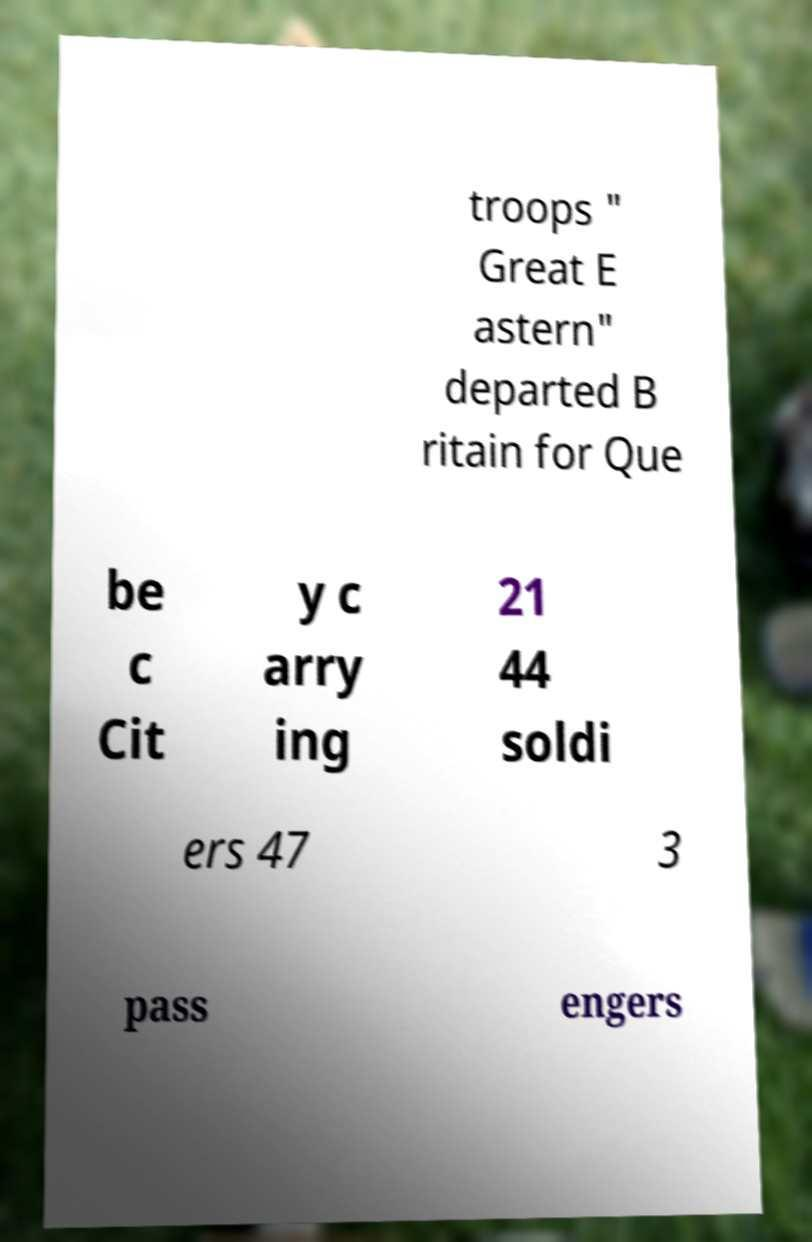Can you read and provide the text displayed in the image?This photo seems to have some interesting text. Can you extract and type it out for me? troops " Great E astern" departed B ritain for Que be c Cit y c arry ing 21 44 soldi ers 47 3 pass engers 